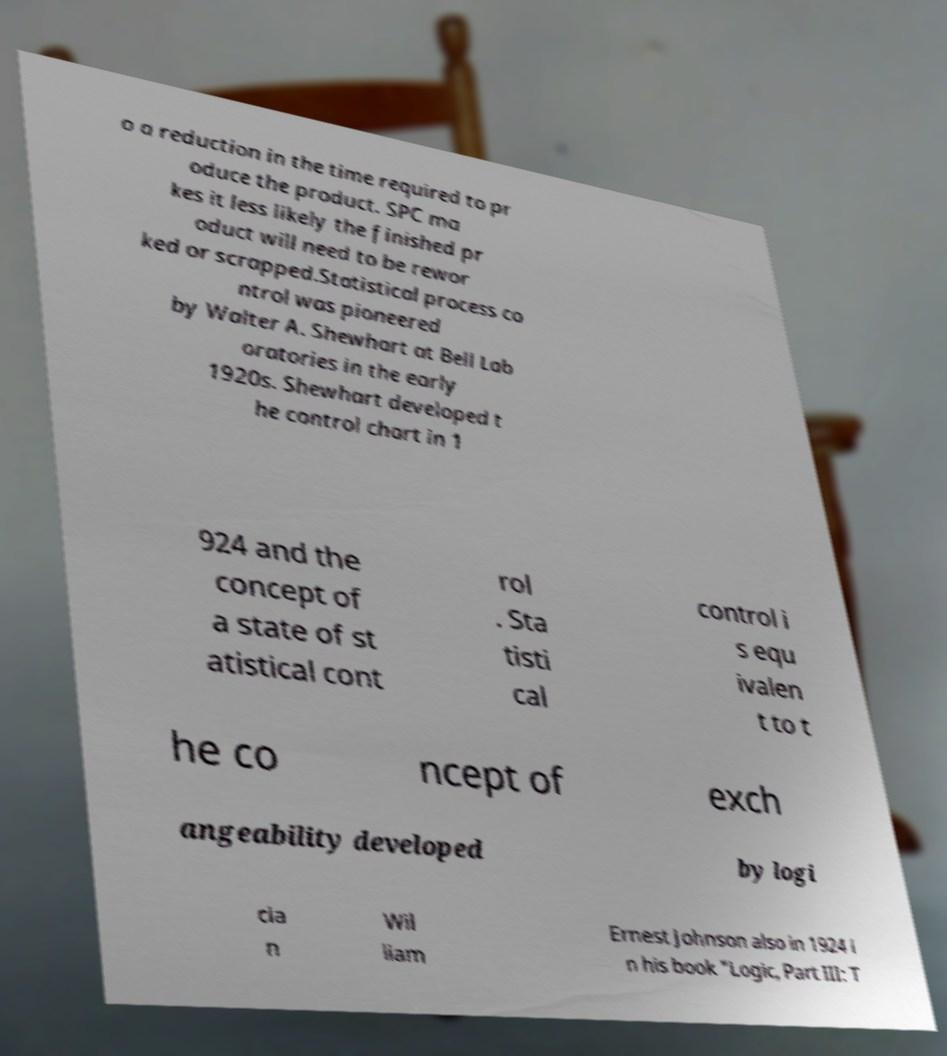For documentation purposes, I need the text within this image transcribed. Could you provide that? o a reduction in the time required to pr oduce the product. SPC ma kes it less likely the finished pr oduct will need to be rewor ked or scrapped.Statistical process co ntrol was pioneered by Walter A. Shewhart at Bell Lab oratories in the early 1920s. Shewhart developed t he control chart in 1 924 and the concept of a state of st atistical cont rol . Sta tisti cal control i s equ ivalen t to t he co ncept of exch angeability developed by logi cia n Wil liam Ernest Johnson also in 1924 i n his book "Logic, Part III: T 